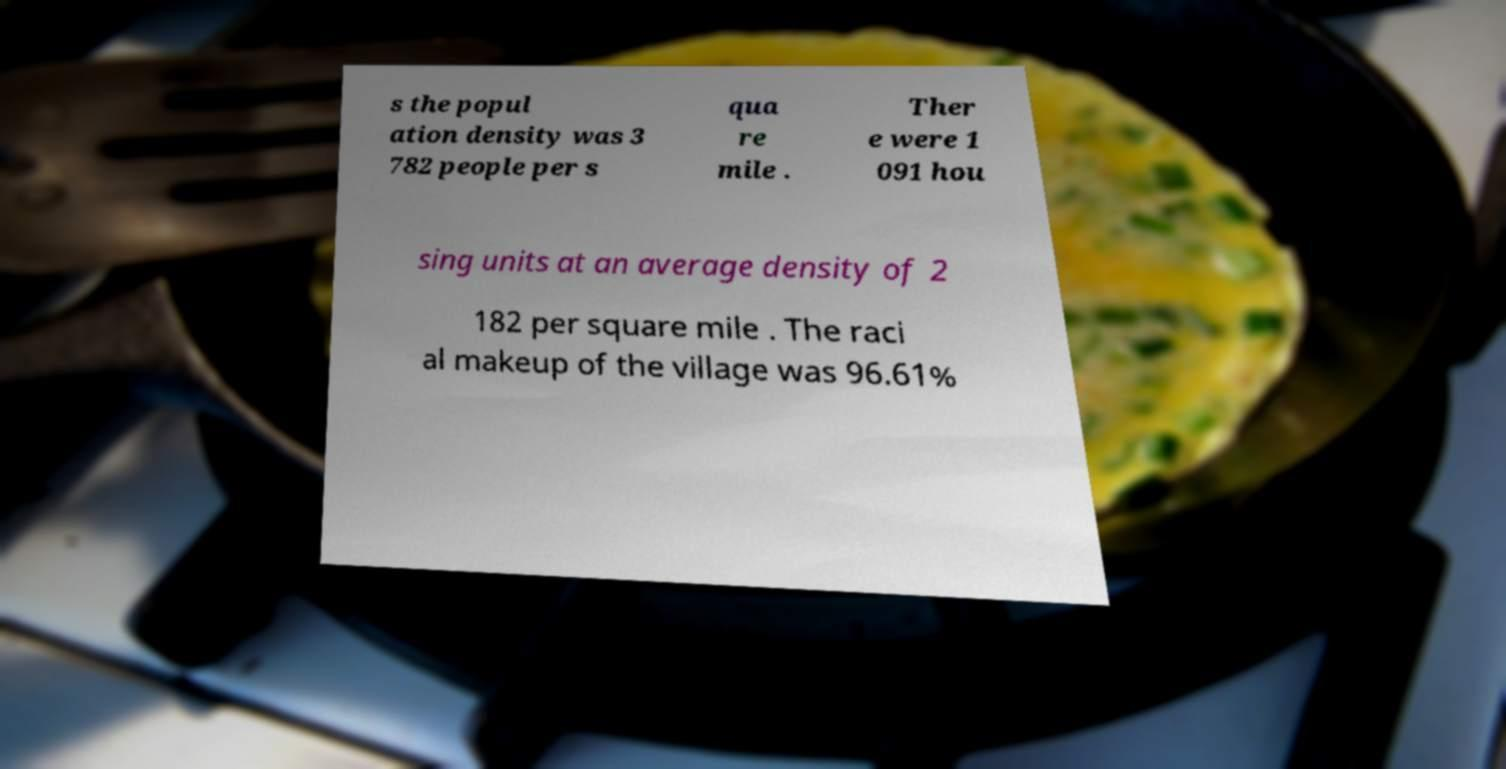For documentation purposes, I need the text within this image transcribed. Could you provide that? s the popul ation density was 3 782 people per s qua re mile . Ther e were 1 091 hou sing units at an average density of 2 182 per square mile . The raci al makeup of the village was 96.61% 